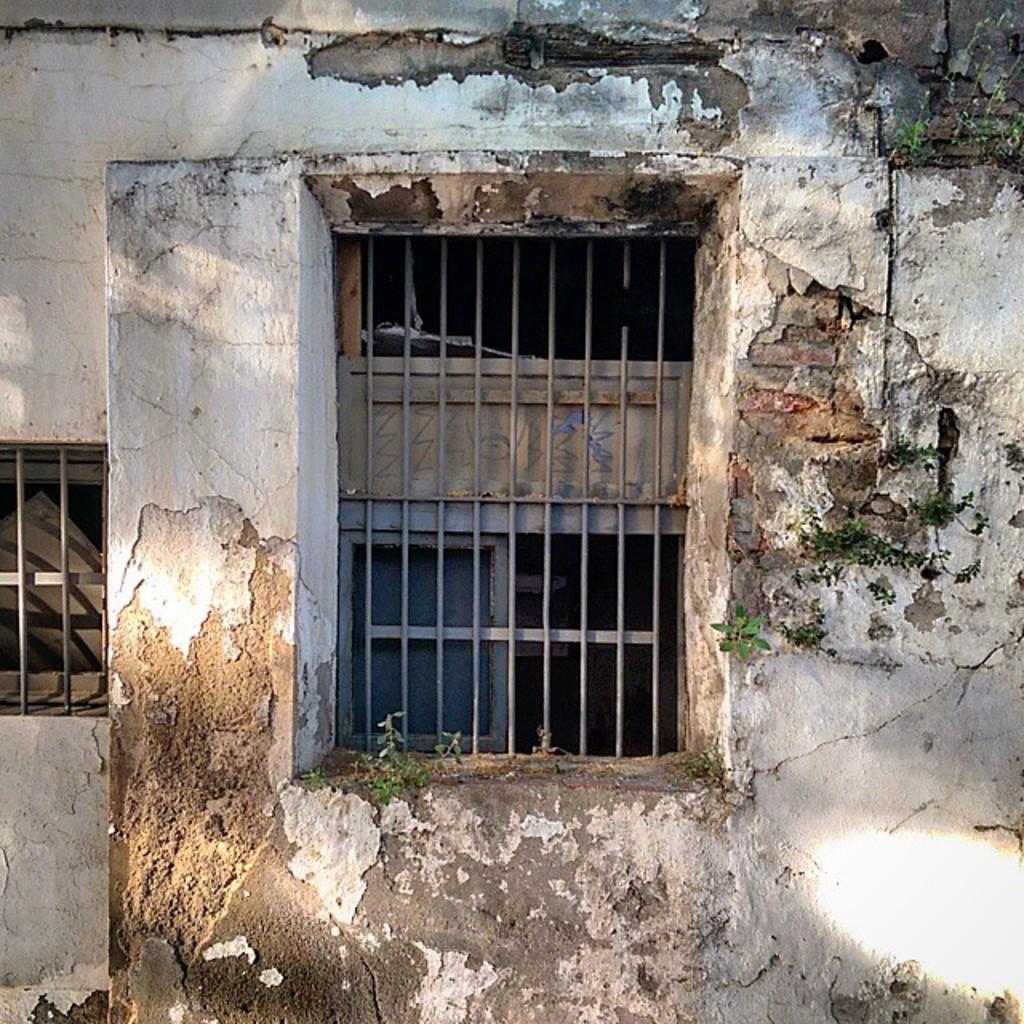In one or two sentences, can you explain what this image depicts? In this image there is a damaged building with window. 